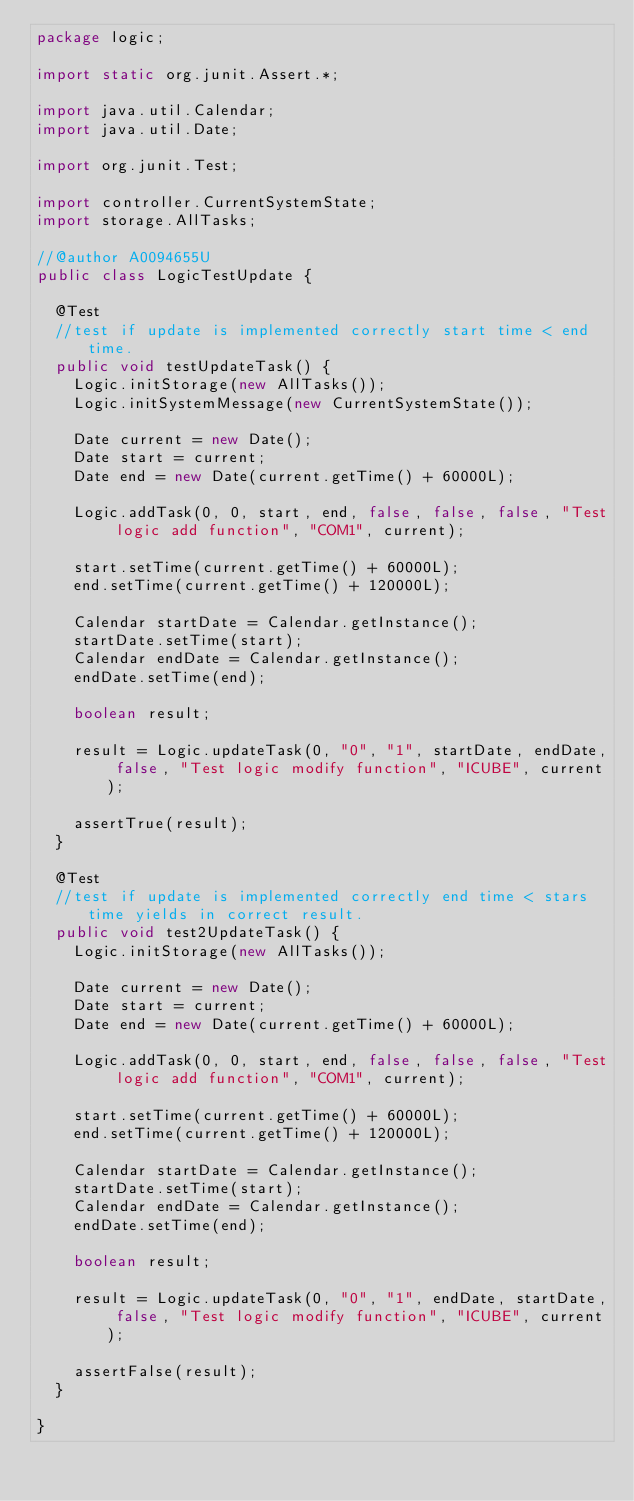<code> <loc_0><loc_0><loc_500><loc_500><_Java_>package logic;

import static org.junit.Assert.*;

import java.util.Calendar;
import java.util.Date;

import org.junit.Test;

import controller.CurrentSystemState;
import storage.AllTasks;

//@author A0094655U
public class LogicTestUpdate {

	@Test
	//test if update is implemented correctly start time < end time.
	public void testUpdateTask() {
		Logic.initStorage(new AllTasks());
		Logic.initSystemMessage(new CurrentSystemState());
		
		Date current = new Date();
		Date start = current;
		Date end = new Date(current.getTime() + 60000L);
		
		Logic.addTask(0, 0, start, end, false, false, false, "Test logic add function", "COM1", current);

		start.setTime(current.getTime() + 60000L);
		end.setTime(current.getTime() + 120000L);
		
		Calendar startDate = Calendar.getInstance();
		startDate.setTime(start);
		Calendar endDate = Calendar.getInstance();
		endDate.setTime(end);
		
		boolean result;
		
		result = Logic.updateTask(0, "0", "1", startDate, endDate, false, "Test logic modify function", "ICUBE", current);
				
		assertTrue(result);
	}
	
	@Test
	//test if update is implemented correctly end time < stars time yields in correct result.
	public void test2UpdateTask() {
		Logic.initStorage(new AllTasks());
		
		Date current = new Date();
		Date start = current;
		Date end = new Date(current.getTime() + 60000L);
		
		Logic.addTask(0, 0, start, end, false, false, false, "Test logic add function", "COM1", current);

		start.setTime(current.getTime() + 60000L);
		end.setTime(current.getTime() + 120000L);
		
		Calendar startDate = Calendar.getInstance();
		startDate.setTime(start);
		Calendar endDate = Calendar.getInstance();
		endDate.setTime(end);
		
		boolean result;
		
		result = Logic.updateTask(0, "0", "1", endDate, startDate, false, "Test logic modify function", "ICUBE", current);
				
		assertFalse(result);
	}

}
</code> 